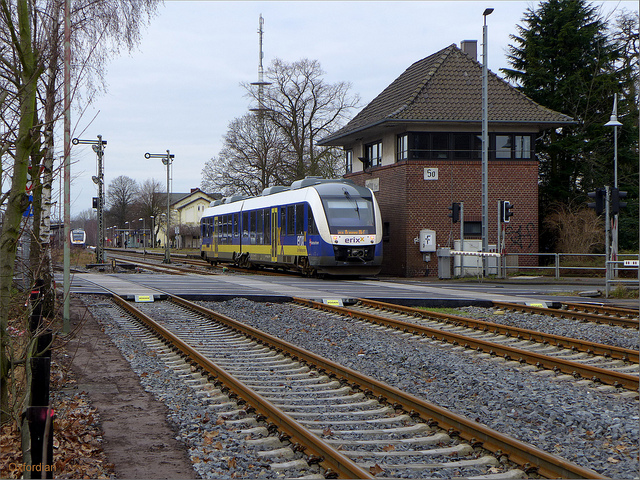Please identify all text content in this image. 50 